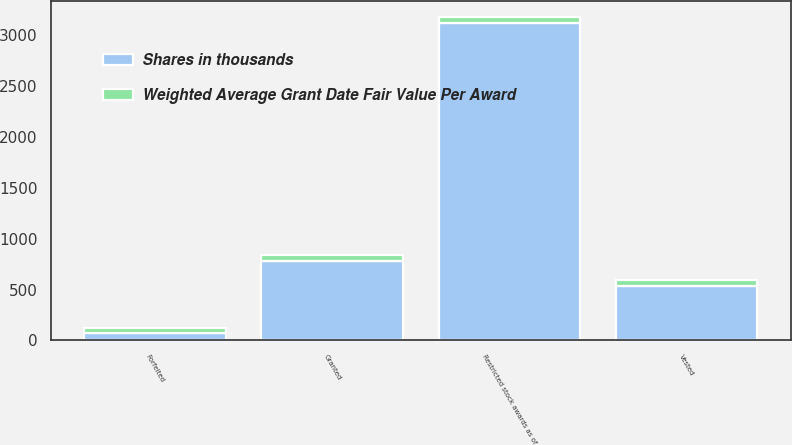<chart> <loc_0><loc_0><loc_500><loc_500><stacked_bar_chart><ecel><fcel>Restricted stock awards as of<fcel>Granted<fcel>Vested<fcel>Forfeited<nl><fcel>Shares in thousands<fcel>3116<fcel>779<fcel>538<fcel>74<nl><fcel>Weighted Average Grant Date Fair Value Per Award<fcel>55<fcel>59<fcel>53<fcel>53<nl></chart> 